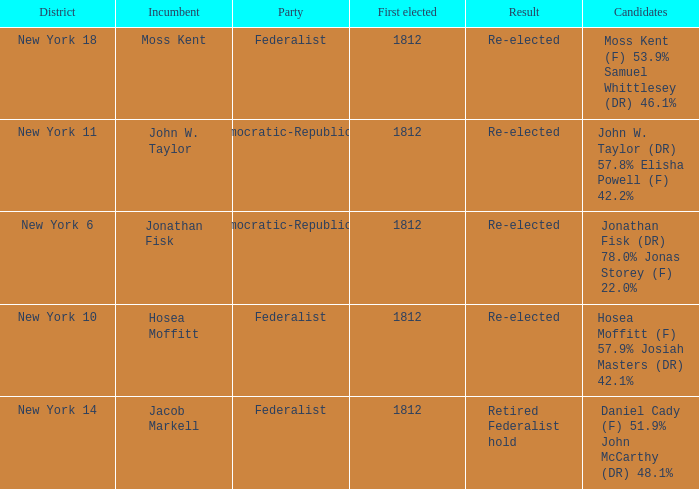Name the incumbent for new york 10 Hosea Moffitt. 